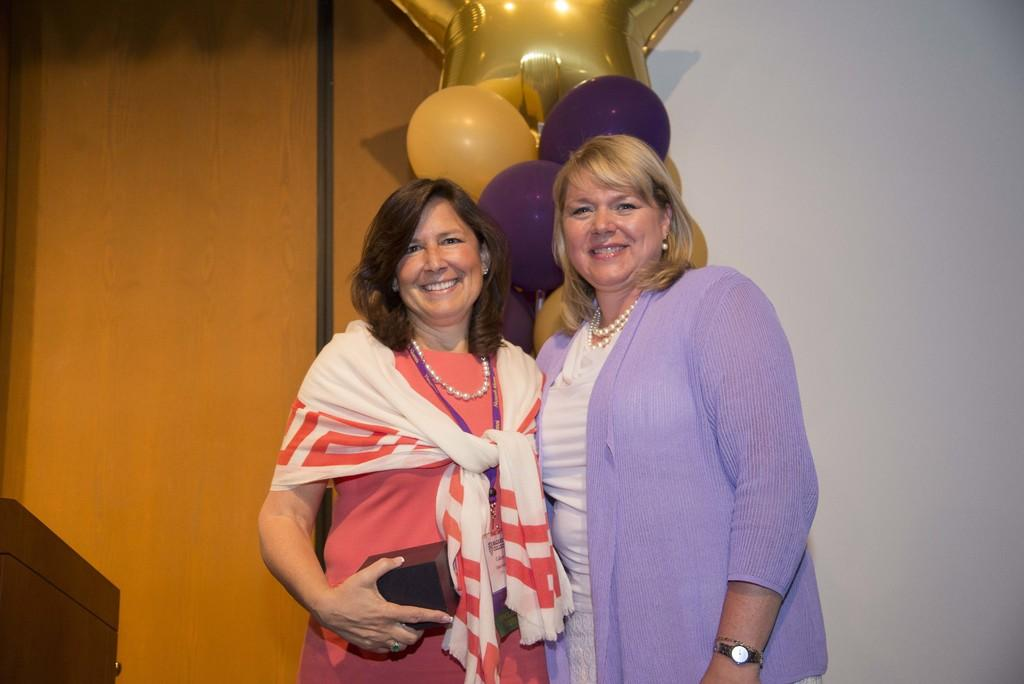How many people are in the center of the image? There are two ladies in the center of the image. What can be seen at the top side of the image? There are balloons at the top side of the image. How many brothers do the ladies have in the image? There is no information about brothers in the image, as it only mentions the presence of two ladies and balloons. 